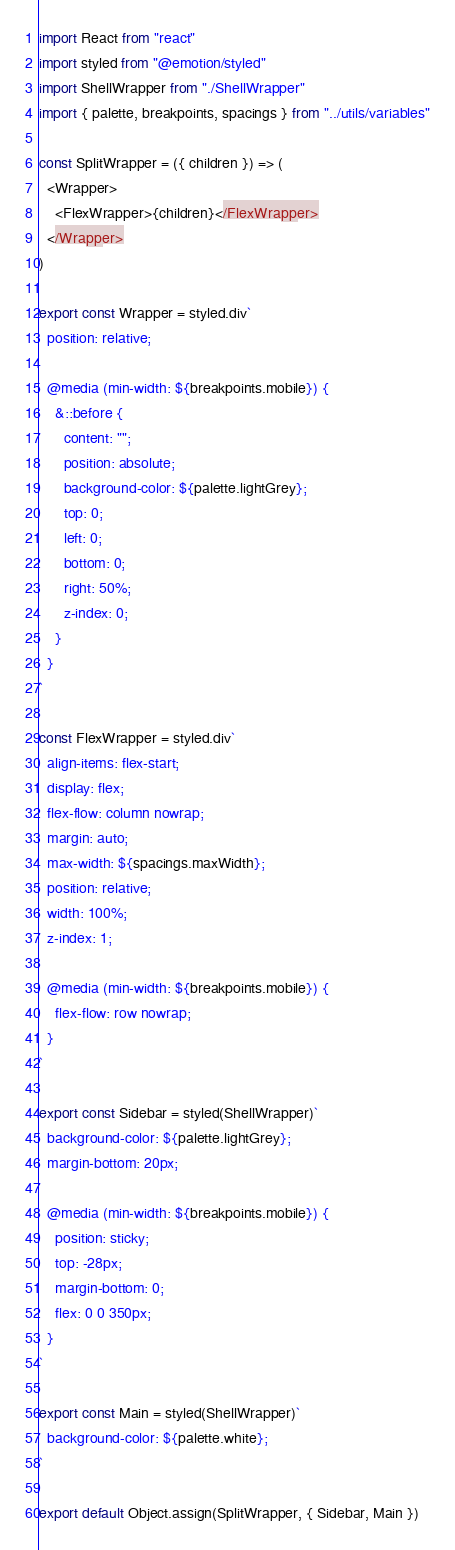Convert code to text. <code><loc_0><loc_0><loc_500><loc_500><_JavaScript_>import React from "react"
import styled from "@emotion/styled"
import ShellWrapper from "./ShellWrapper"
import { palette, breakpoints, spacings } from "../utils/variables"

const SplitWrapper = ({ children }) => (
  <Wrapper>
    <FlexWrapper>{children}</FlexWrapper>
  </Wrapper>
)

export const Wrapper = styled.div`
  position: relative;

  @media (min-width: ${breakpoints.mobile}) {
    &::before {
      content: "";
      position: absolute;
      background-color: ${palette.lightGrey};
      top: 0;
      left: 0;
      bottom: 0;
      right: 50%;
      z-index: 0;
    }
  }
`

const FlexWrapper = styled.div`
  align-items: flex-start;
  display: flex;
  flex-flow: column nowrap;
  margin: auto;
  max-width: ${spacings.maxWidth};
  position: relative;
  width: 100%;
  z-index: 1;

  @media (min-width: ${breakpoints.mobile}) {
    flex-flow: row nowrap;
  }
`

export const Sidebar = styled(ShellWrapper)`
  background-color: ${palette.lightGrey};
  margin-bottom: 20px;

  @media (min-width: ${breakpoints.mobile}) {
    position: sticky;
    top: -28px;
    margin-bottom: 0;
    flex: 0 0 350px;
  }
`

export const Main = styled(ShellWrapper)`
  background-color: ${palette.white};
`

export default Object.assign(SplitWrapper, { Sidebar, Main })
</code> 